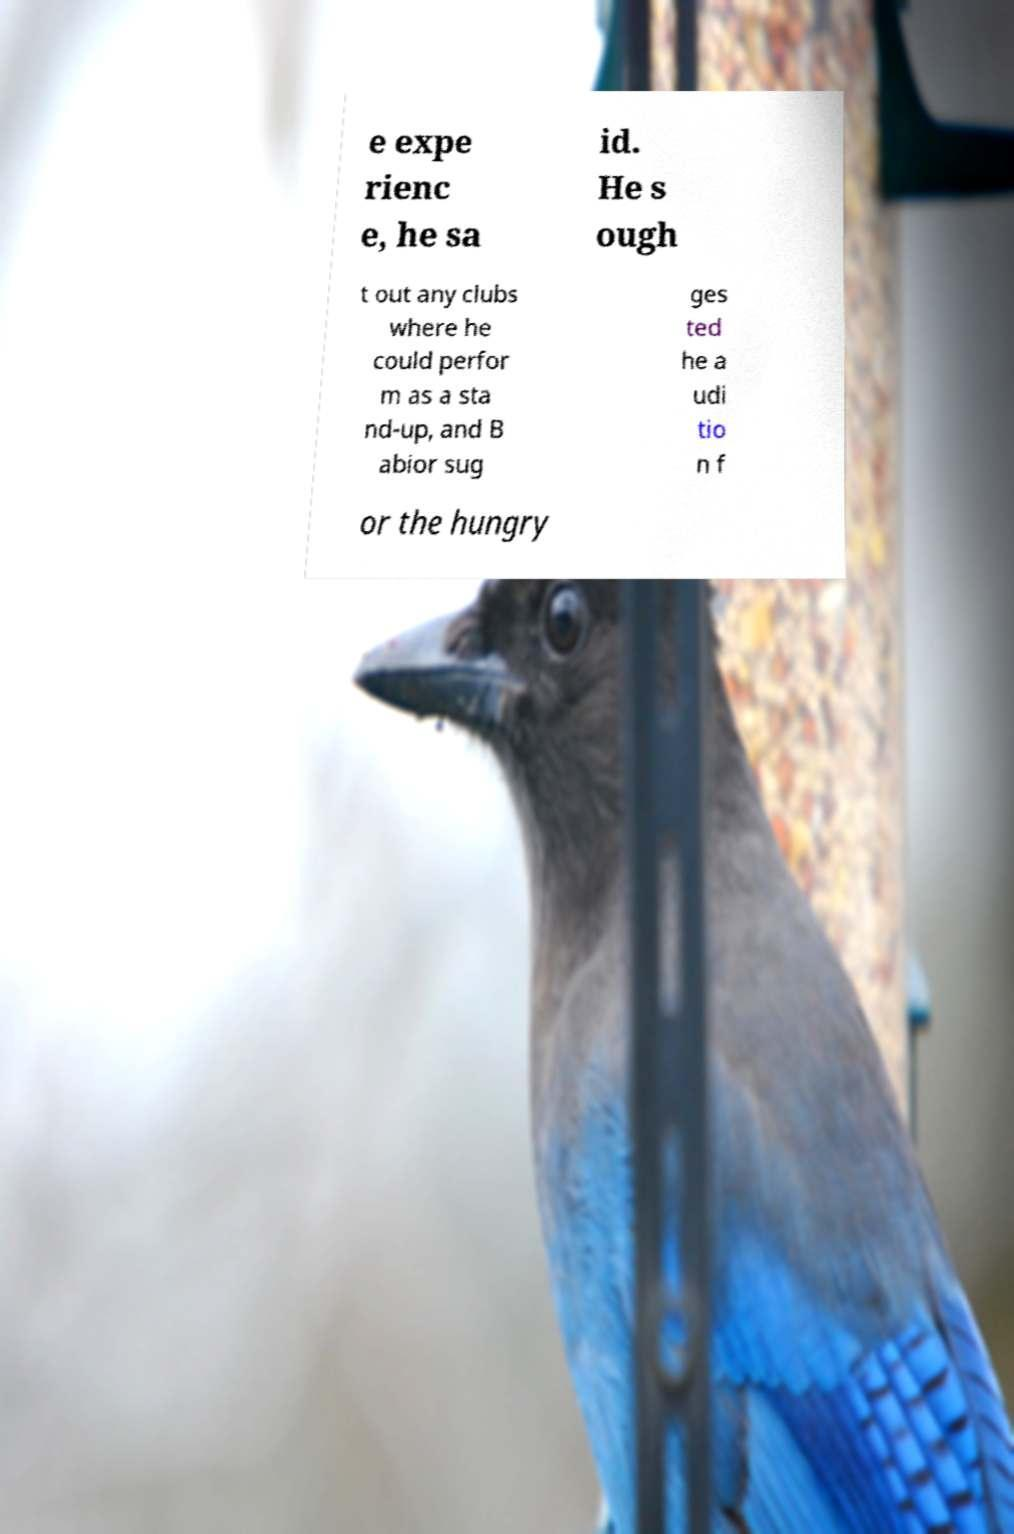Can you accurately transcribe the text from the provided image for me? e expe rienc e, he sa id. He s ough t out any clubs where he could perfor m as a sta nd-up, and B abior sug ges ted he a udi tio n f or the hungry 